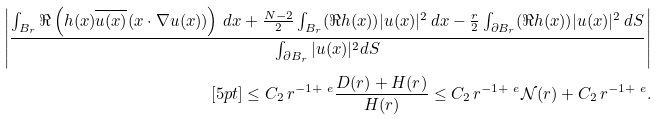<formula> <loc_0><loc_0><loc_500><loc_500>\left | \frac { \int _ { B _ { r } } \Re \left ( h ( x ) \overline { u ( x ) } ( x \cdot \nabla u ( x ) ) \right ) \, d x + \frac { N - 2 } 2 \int _ { B _ { r } } ( \Re h ( x ) ) | u ( x ) | ^ { 2 } \, d x - \frac { r } { 2 } \int _ { \partial B _ { r } } ( \Re h ( x ) ) | u ( x ) | ^ { 2 } \, d S } { \int _ { \partial B _ { r } } | u ( x ) | ^ { 2 } d S } \right | \\ [ 5 p t ] \leq C _ { 2 } \, r ^ { - 1 + \ e } \frac { D ( r ) + H ( r ) } { H ( r ) } \leq C _ { 2 } \, r ^ { - 1 + \ e } { \mathcal { N } } ( r ) + C _ { 2 } \, r ^ { - 1 + \ e } .</formula> 